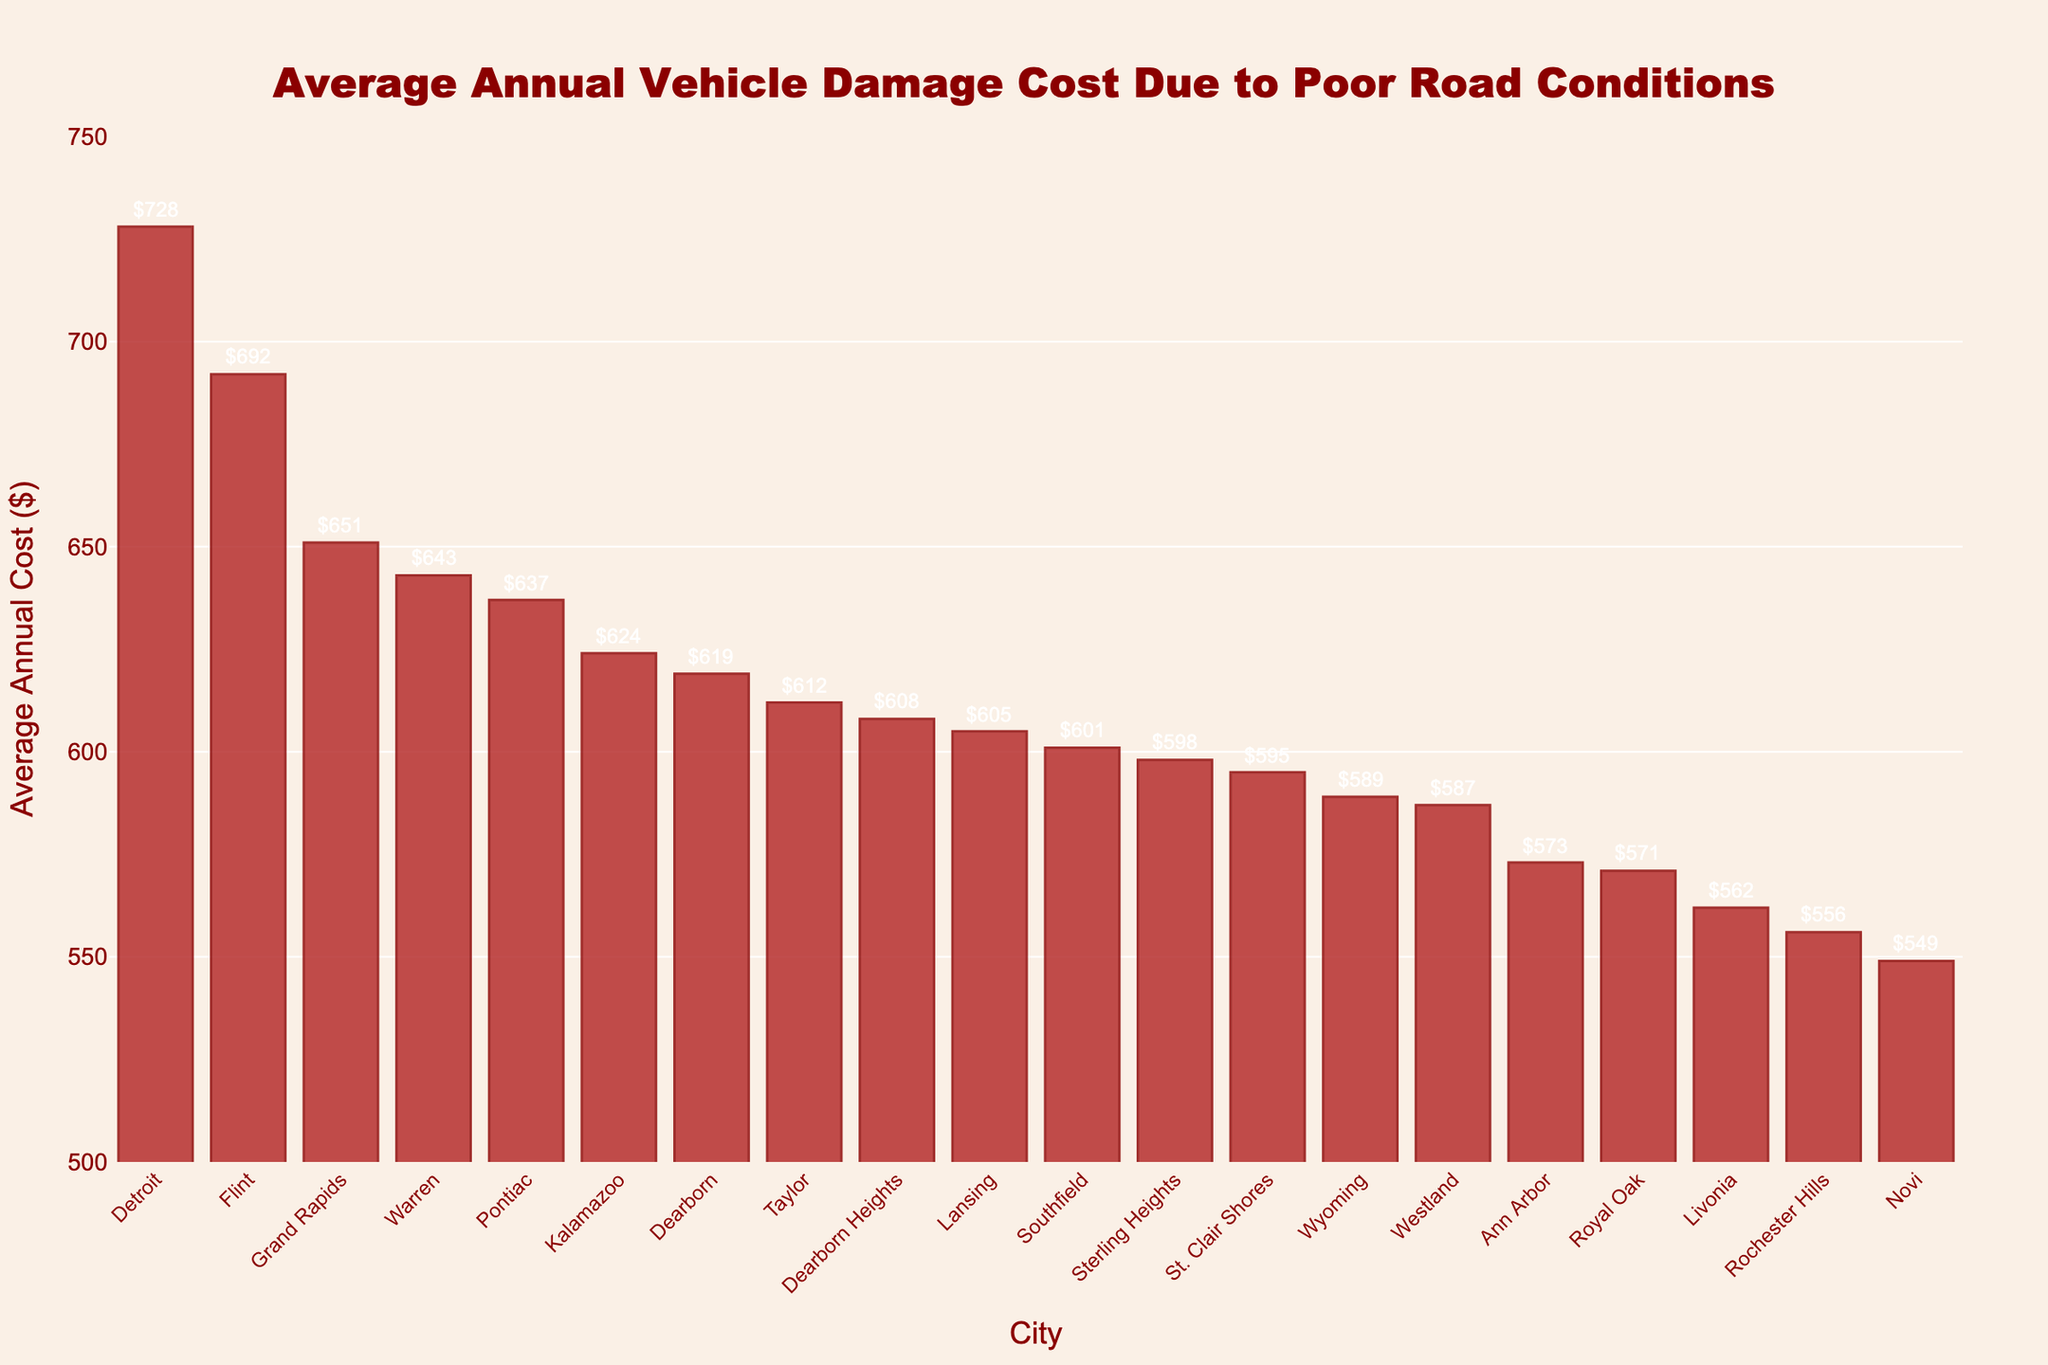Which city has the highest average annual vehicle damage cost? The bar chart shows 'Detroit' with the tallest bar, indicating the highest cost value of $728.
Answer: Detroit What is the average annual vehicle damage cost for Ann Arbor? From the chart, the bar for Ann Arbor has a label of $573.
Answer: $573 Which two cities have the lowest average annual vehicle damage costs, and what are those costs? The shortest bars in the chart belong to Novi and Rochester Hills, with costs of $549 and $556, respectively.
Answer: Novi: $549, Rochester Hills: $556 How much higher is the vehicle damage cost in Detroit compared to Lansing? Detroit has a cost of $728 and Lansing $605. The difference is $728 - $605.
Answer: $123 What is the total average annual vehicle damage cost for cities Detroit and Grand Rapids? The costs for Detroit and Grand Rapids are $728 and $651, respectively. Their sum is $728 + $651.
Answer: $1379 Which cities have an average vehicle damage cost greater than $600 but less than $700? From the chart, Flint, Lansing, Dearborn, Warren, Kalamazoo, Pontiac, and Dearborn Heights have costs within the specified range.
Answer: Flint, Lansing, Dearborn, Warren, Kalamazoo, Pontiac, Dearborn Heights In terms of vehicle damage costs, how does Kalamazoo compare to Westland? The chart shows Kalamazoo with a cost of $624 and Westland with $587, making Kalamazoo's cost higher by $624 - $587.
Answer: $37 higher Are there any cities with a vehicle damage cost of exactly $600? The chart shows Southfield has a cost that appears to be exactly $601, none at exactly $600.
Answer: No What is the visual color of the bars in the chart? All bars in the chart are colored in shades of red, specifically firebrick with dark red borders.
Answer: Red How many cities have an average vehicle damage cost above $650? By counting the bars above the $650 line, we find three cities: Detroit, Grand Rapids, and Flint.
Answer: Three 